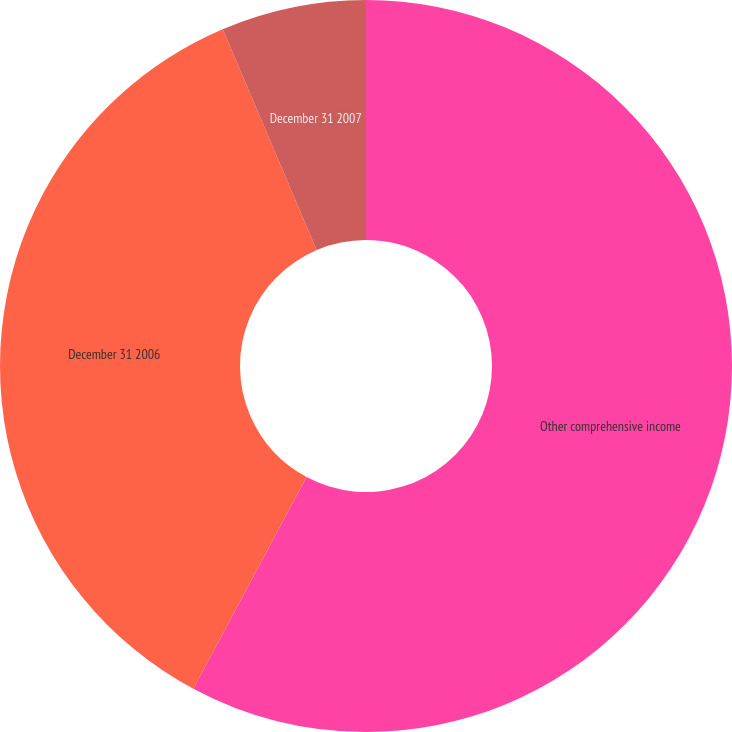Convert chart. <chart><loc_0><loc_0><loc_500><loc_500><pie_chart><fcel>Other comprehensive income<fcel>December 31 2006<fcel>December 31 2007<nl><fcel>57.82%<fcel>35.78%<fcel>6.4%<nl></chart> 